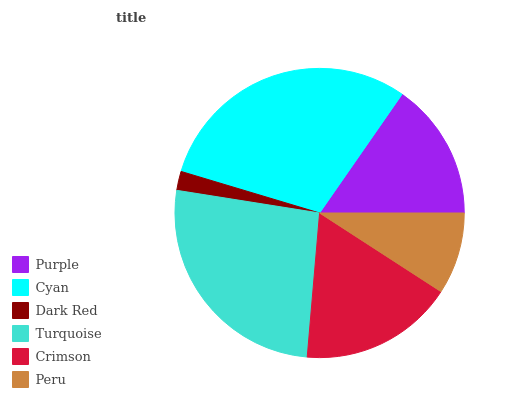Is Dark Red the minimum?
Answer yes or no. Yes. Is Cyan the maximum?
Answer yes or no. Yes. Is Cyan the minimum?
Answer yes or no. No. Is Dark Red the maximum?
Answer yes or no. No. Is Cyan greater than Dark Red?
Answer yes or no. Yes. Is Dark Red less than Cyan?
Answer yes or no. Yes. Is Dark Red greater than Cyan?
Answer yes or no. No. Is Cyan less than Dark Red?
Answer yes or no. No. Is Crimson the high median?
Answer yes or no. Yes. Is Purple the low median?
Answer yes or no. Yes. Is Turquoise the high median?
Answer yes or no. No. Is Cyan the low median?
Answer yes or no. No. 